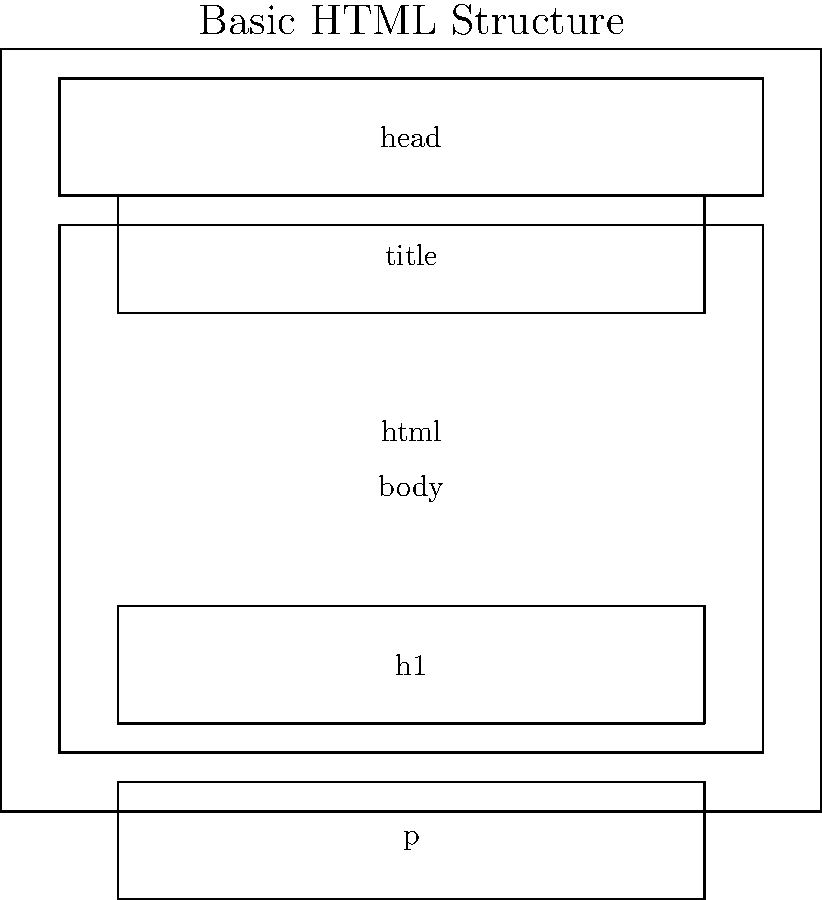In the given HTML structure diagram, which element is typically used to contain metadata about the HTML document and is not visible in the browser window? To answer this question, let's examine the basic structure of an HTML document as shown in the diagram:

1. The outermost element is the `<html>` tag, which encapsulates the entire HTML document.

2. Inside the `<html>` tag, we see two main sections:
   a) The `<head>` section
   b) The `<body>` section

3. The `<head>` section is located at the top of the document structure.

4. The `<head>` section typically contains elements that are not directly visible in the browser window, such as:
   - The `<title>` tag (which is shown in the diagram)
   - Other metadata tags like `<meta>`, `<link>`, and `<script>`

5. The `<body>` section, on the other hand, contains the visible content of the web page, such as headings (`<h1>`) and paragraphs (`<p>`).

6. By definition, the `<head>` section is used to contain metadata about the HTML document, which is not directly visible in the browser window.

Therefore, the element that typically contains metadata about the HTML document and is not visible in the browser window is the `<head>` element.
Answer: head 